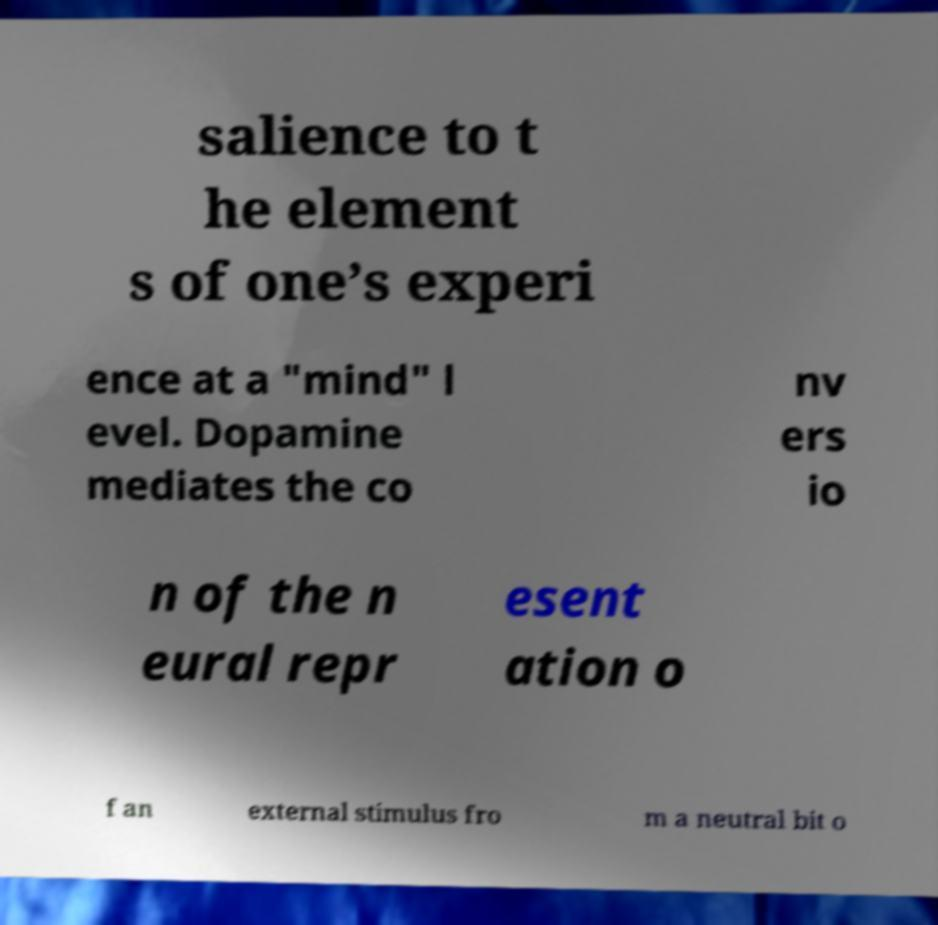Can you read and provide the text displayed in the image?This photo seems to have some interesting text. Can you extract and type it out for me? salience to t he element s of one’s experi ence at a "mind" l evel. Dopamine mediates the co nv ers io n of the n eural repr esent ation o f an external stimulus fro m a neutral bit o 